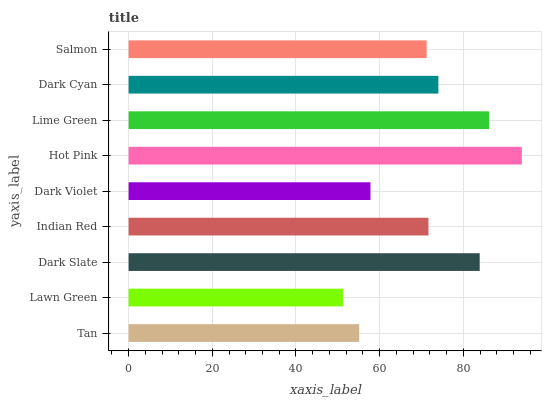Is Lawn Green the minimum?
Answer yes or no. Yes. Is Hot Pink the maximum?
Answer yes or no. Yes. Is Dark Slate the minimum?
Answer yes or no. No. Is Dark Slate the maximum?
Answer yes or no. No. Is Dark Slate greater than Lawn Green?
Answer yes or no. Yes. Is Lawn Green less than Dark Slate?
Answer yes or no. Yes. Is Lawn Green greater than Dark Slate?
Answer yes or no. No. Is Dark Slate less than Lawn Green?
Answer yes or no. No. Is Indian Red the high median?
Answer yes or no. Yes. Is Indian Red the low median?
Answer yes or no. Yes. Is Tan the high median?
Answer yes or no. No. Is Salmon the low median?
Answer yes or no. No. 